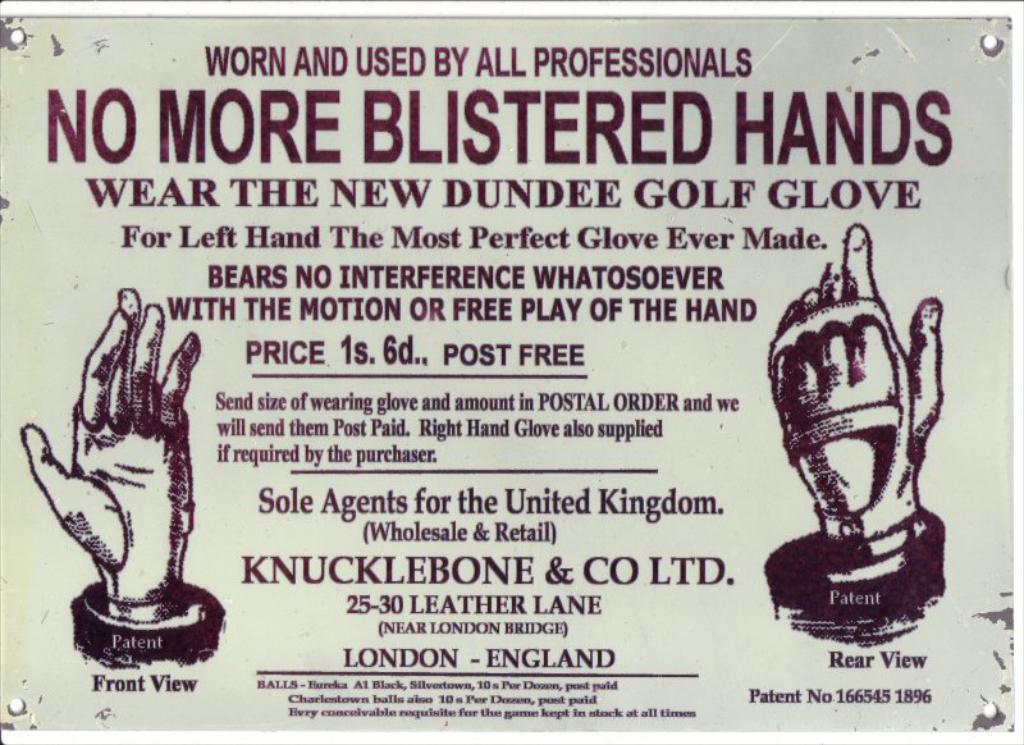What is the advertisement trying to sell?
Offer a terse response. Golf glove. What city in england is listed?
Provide a succinct answer. London. 